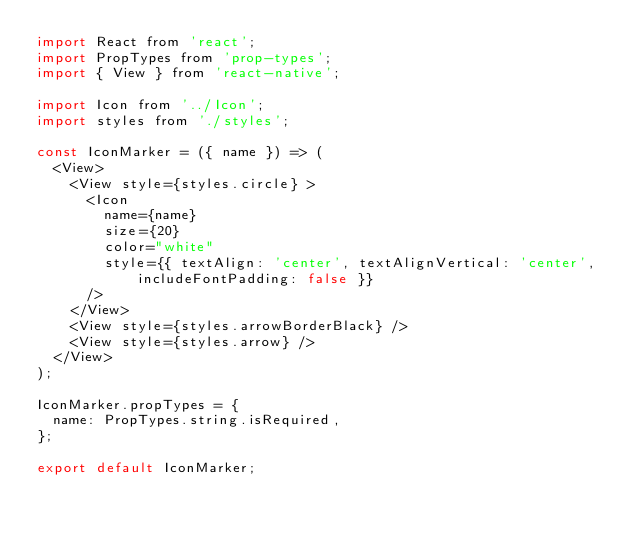Convert code to text. <code><loc_0><loc_0><loc_500><loc_500><_JavaScript_>import React from 'react';
import PropTypes from 'prop-types';
import { View } from 'react-native';

import Icon from '../Icon';
import styles from './styles';

const IconMarker = ({ name }) => (
  <View>
    <View style={styles.circle} >
      <Icon
        name={name}
        size={20}
        color="white"
        style={{ textAlign: 'center', textAlignVertical: 'center', includeFontPadding: false }}
      />
    </View>
    <View style={styles.arrowBorderBlack} />
    <View style={styles.arrow} />
  </View>
);

IconMarker.propTypes = {
  name: PropTypes.string.isRequired,
};

export default IconMarker;
</code> 